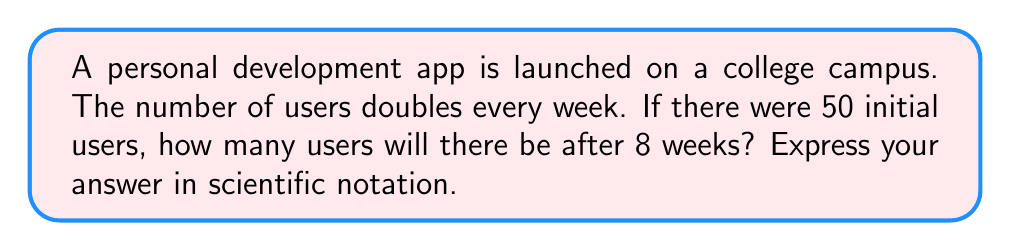Provide a solution to this math problem. Let's approach this step-by-step:

1) We start with an initial number of users: $N_0 = 50$

2) The number of users doubles every week, so we can represent this as an exponential function:
   $N(t) = N_0 \cdot 2^t$
   where $t$ is the number of weeks

3) We want to know the number of users after 8 weeks, so $t = 8$

4) Let's substitute these values into our equation:
   $N(8) = 50 \cdot 2^8$

5) Now, let's calculate:
   $N(8) = 50 \cdot 256 = 12,800$

6) To express this in scientific notation, we move the decimal point to the left until we have a number between 1 and 10, and then count how many places we moved:
   $12,800 = 1.28 \times 10^4$

Therefore, after 8 weeks, there will be $1.28 \times 10^4$ users.
Answer: $1.28 \times 10^4$ 